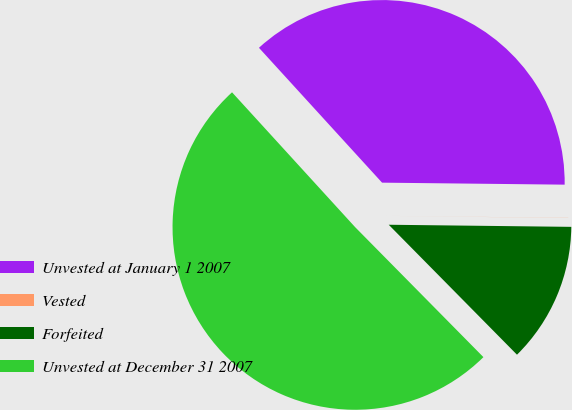<chart> <loc_0><loc_0><loc_500><loc_500><pie_chart><fcel>Unvested at January 1 2007<fcel>Vested<fcel>Forfeited<fcel>Unvested at December 31 2007<nl><fcel>36.95%<fcel>0.01%<fcel>12.42%<fcel>50.62%<nl></chart> 